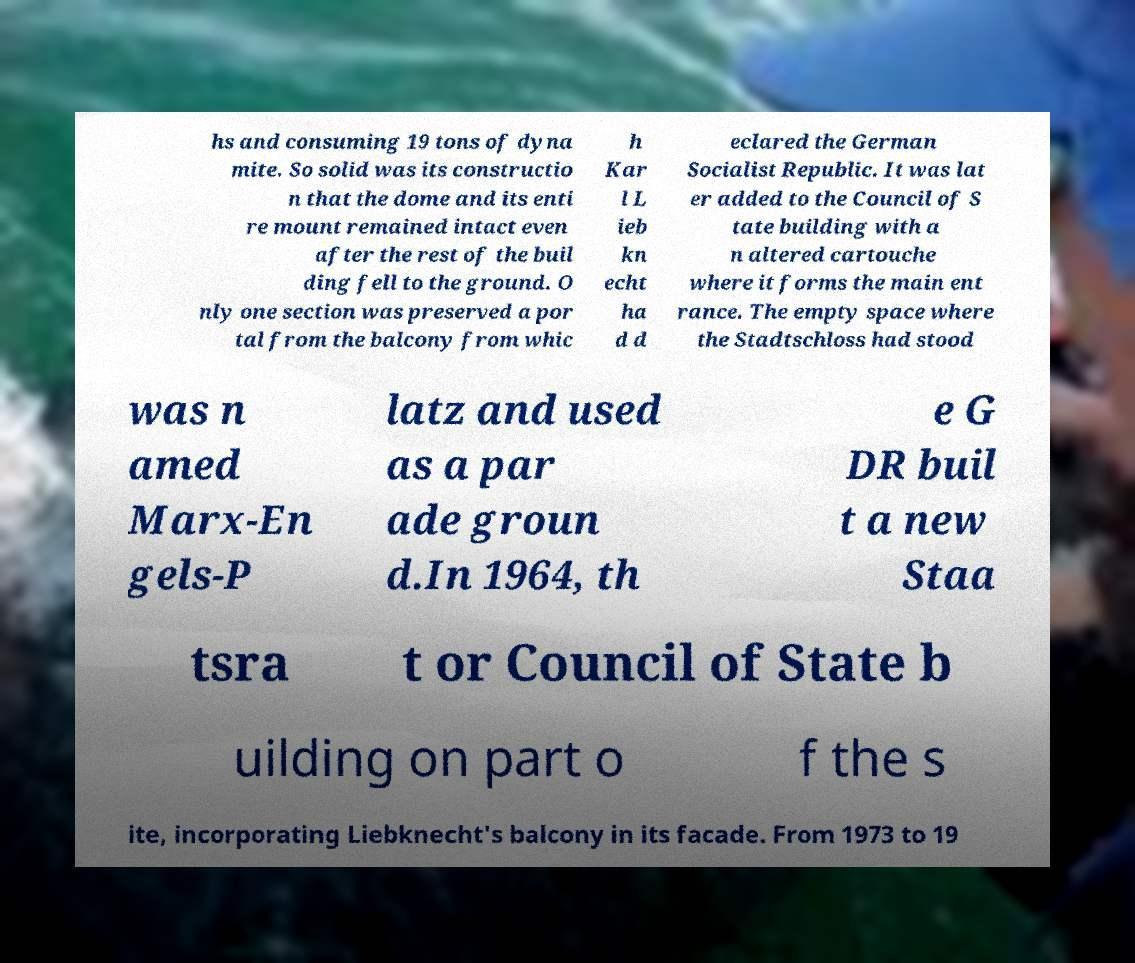There's text embedded in this image that I need extracted. Can you transcribe it verbatim? hs and consuming 19 tons of dyna mite. So solid was its constructio n that the dome and its enti re mount remained intact even after the rest of the buil ding fell to the ground. O nly one section was preserved a por tal from the balcony from whic h Kar l L ieb kn echt ha d d eclared the German Socialist Republic. It was lat er added to the Council of S tate building with a n altered cartouche where it forms the main ent rance. The empty space where the Stadtschloss had stood was n amed Marx-En gels-P latz and used as a par ade groun d.In 1964, th e G DR buil t a new Staa tsra t or Council of State b uilding on part o f the s ite, incorporating Liebknecht's balcony in its facade. From 1973 to 19 